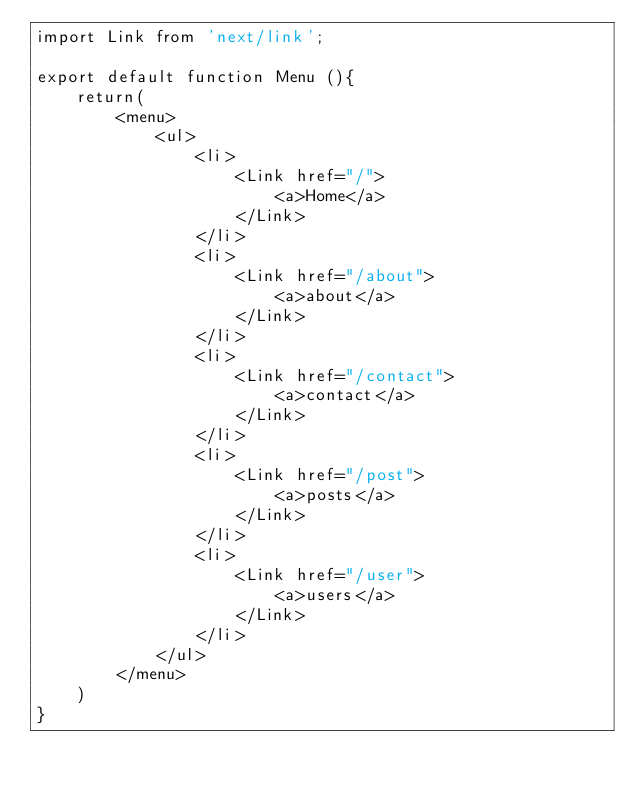Convert code to text. <code><loc_0><loc_0><loc_500><loc_500><_JavaScript_>import Link from 'next/link';

export default function Menu (){
    return(
        <menu>
            <ul>
                <li>
                    <Link href="/">
                        <a>Home</a>
                    </Link>
                </li>
                <li>
                    <Link href="/about">
                        <a>about</a>
                    </Link>
                </li>
                <li>
                    <Link href="/contact">
                        <a>contact</a>
                    </Link>
                </li>
                <li>
                    <Link href="/post">
                        <a>posts</a>
                    </Link>
                </li>
                <li>
                    <Link href="/user">
                        <a>users</a>
                    </Link>
                </li>
            </ul>
        </menu>
    )
}</code> 